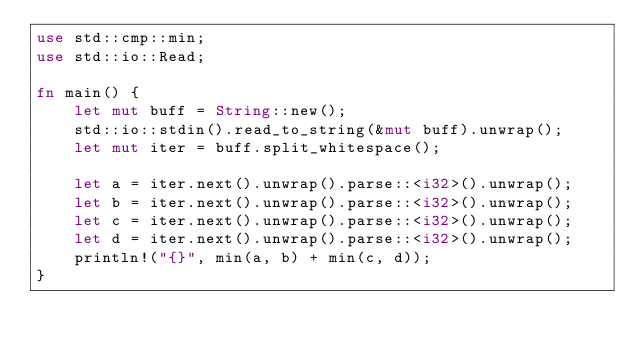<code> <loc_0><loc_0><loc_500><loc_500><_Rust_>use std::cmp::min;
use std::io::Read;

fn main() {
    let mut buff = String::new();
    std::io::stdin().read_to_string(&mut buff).unwrap();
    let mut iter = buff.split_whitespace();

    let a = iter.next().unwrap().parse::<i32>().unwrap();
    let b = iter.next().unwrap().parse::<i32>().unwrap();
    let c = iter.next().unwrap().parse::<i32>().unwrap();
    let d = iter.next().unwrap().parse::<i32>().unwrap();
    println!("{}", min(a, b) + min(c, d));
}
</code> 